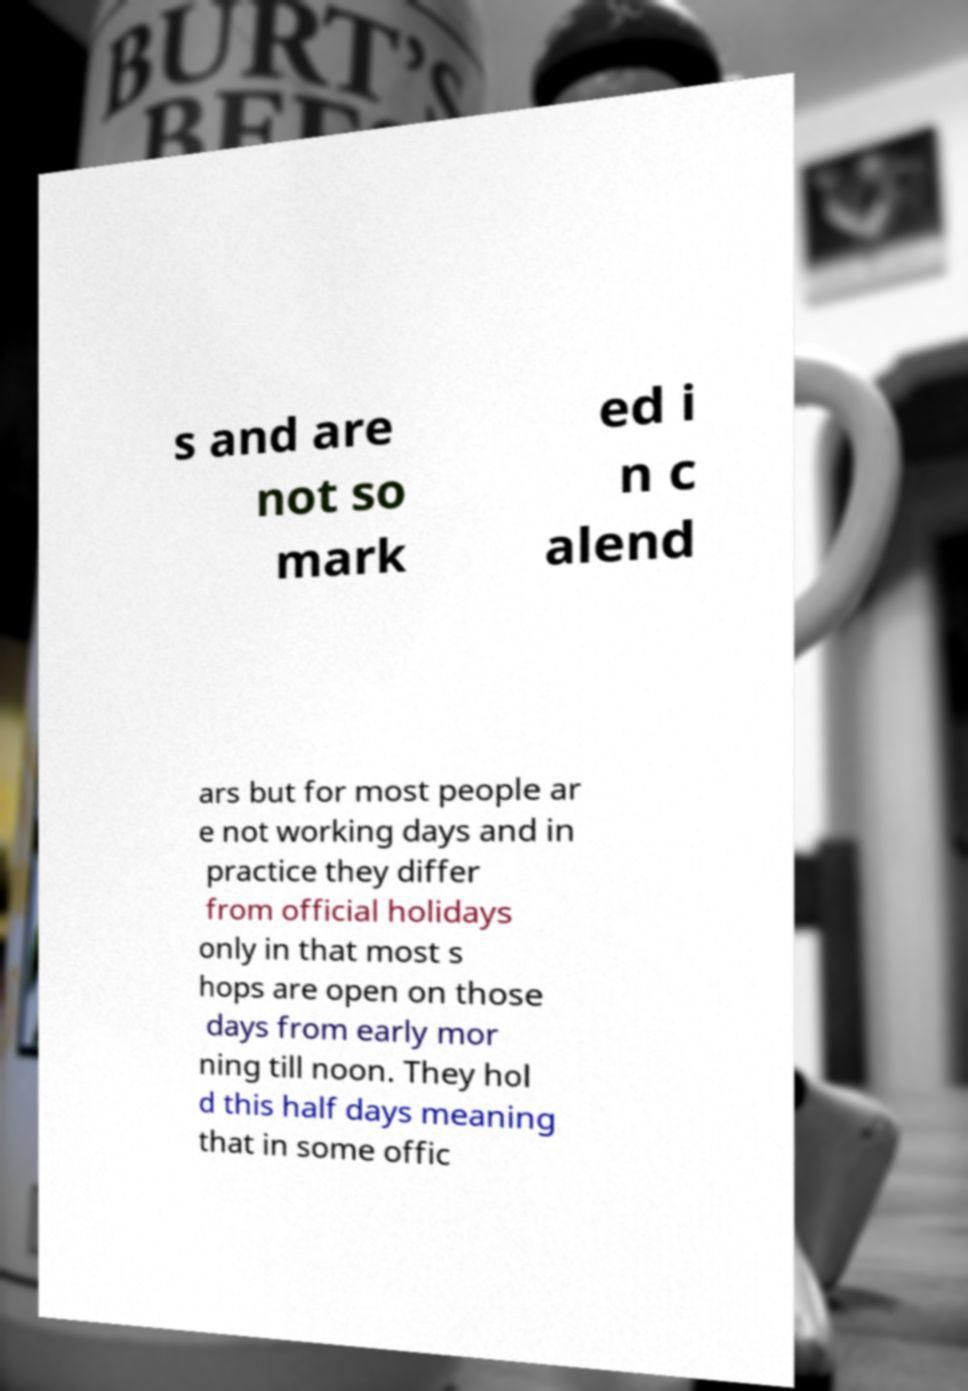Please read and relay the text visible in this image. What does it say? s and are not so mark ed i n c alend ars but for most people ar e not working days and in practice they differ from official holidays only in that most s hops are open on those days from early mor ning till noon. They hol d this half days meaning that in some offic 